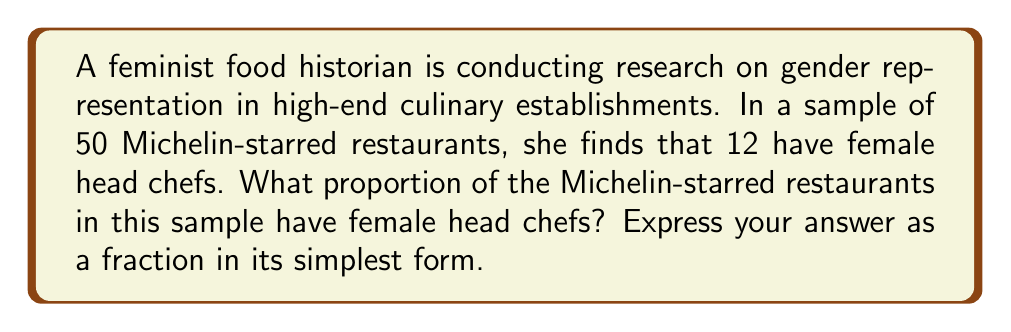Help me with this question. To solve this problem, we need to determine the ratio of female head chefs to the total number of restaurants in the sample. Let's break it down step-by-step:

1. Total number of restaurants in the sample: 50
2. Number of restaurants with female head chefs: 12

The proportion is calculated by dividing the number of restaurants with female head chefs by the total number of restaurants:

$$ \text{Proportion} = \frac{\text{Number of restaurants with female head chefs}}{\text{Total number of restaurants}} $$

$$ \text{Proportion} = \frac{12}{50} $$

To simplify this fraction, we need to find the greatest common divisor (GCD) of 12 and 50:

$$ \text{GCD}(12, 50) = 2 $$

Now, we can divide both the numerator and denominator by 2:

$$ \frac{12 \div 2}{50 \div 2} = \frac{6}{25} $$

Therefore, the simplified fraction representing the proportion of Michelin-starred restaurants with female head chefs in this sample is $\frac{6}{25}$.
Answer: $\frac{6}{25}$ 